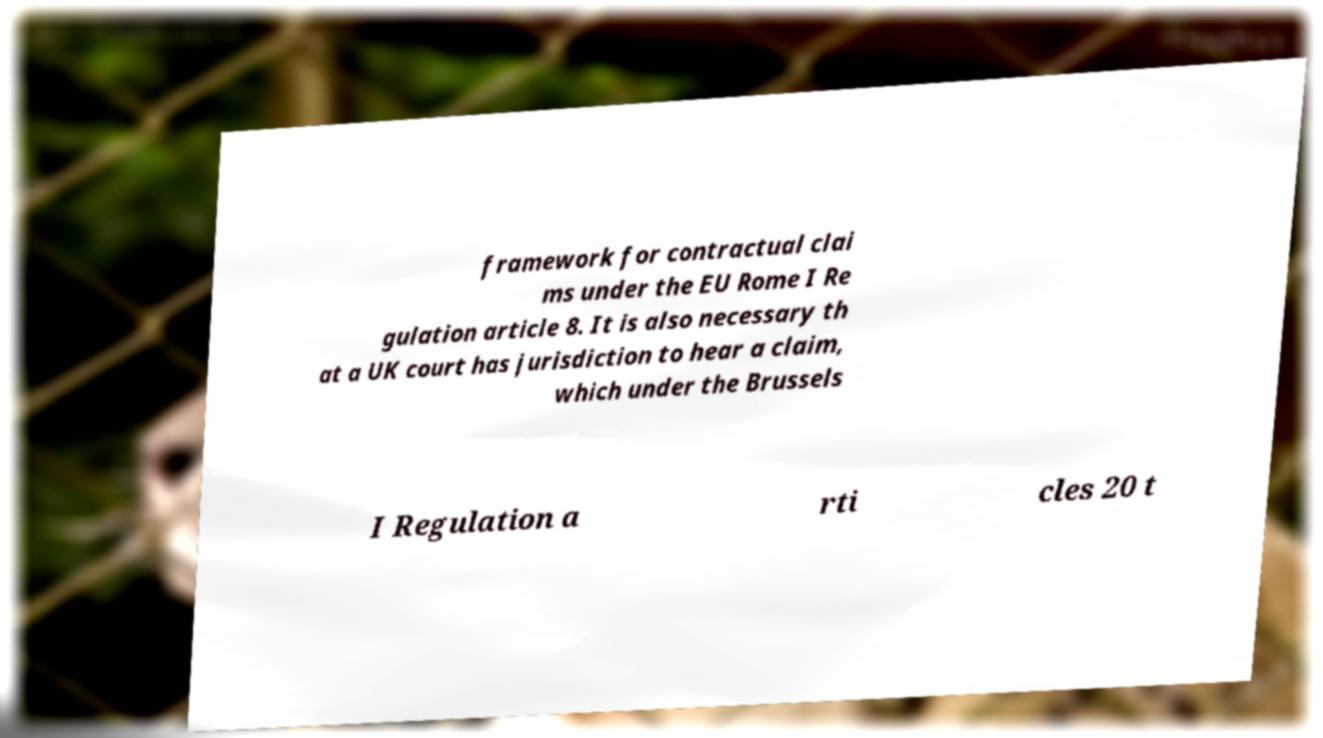What messages or text are displayed in this image? I need them in a readable, typed format. framework for contractual clai ms under the EU Rome I Re gulation article 8. It is also necessary th at a UK court has jurisdiction to hear a claim, which under the Brussels I Regulation a rti cles 20 t 